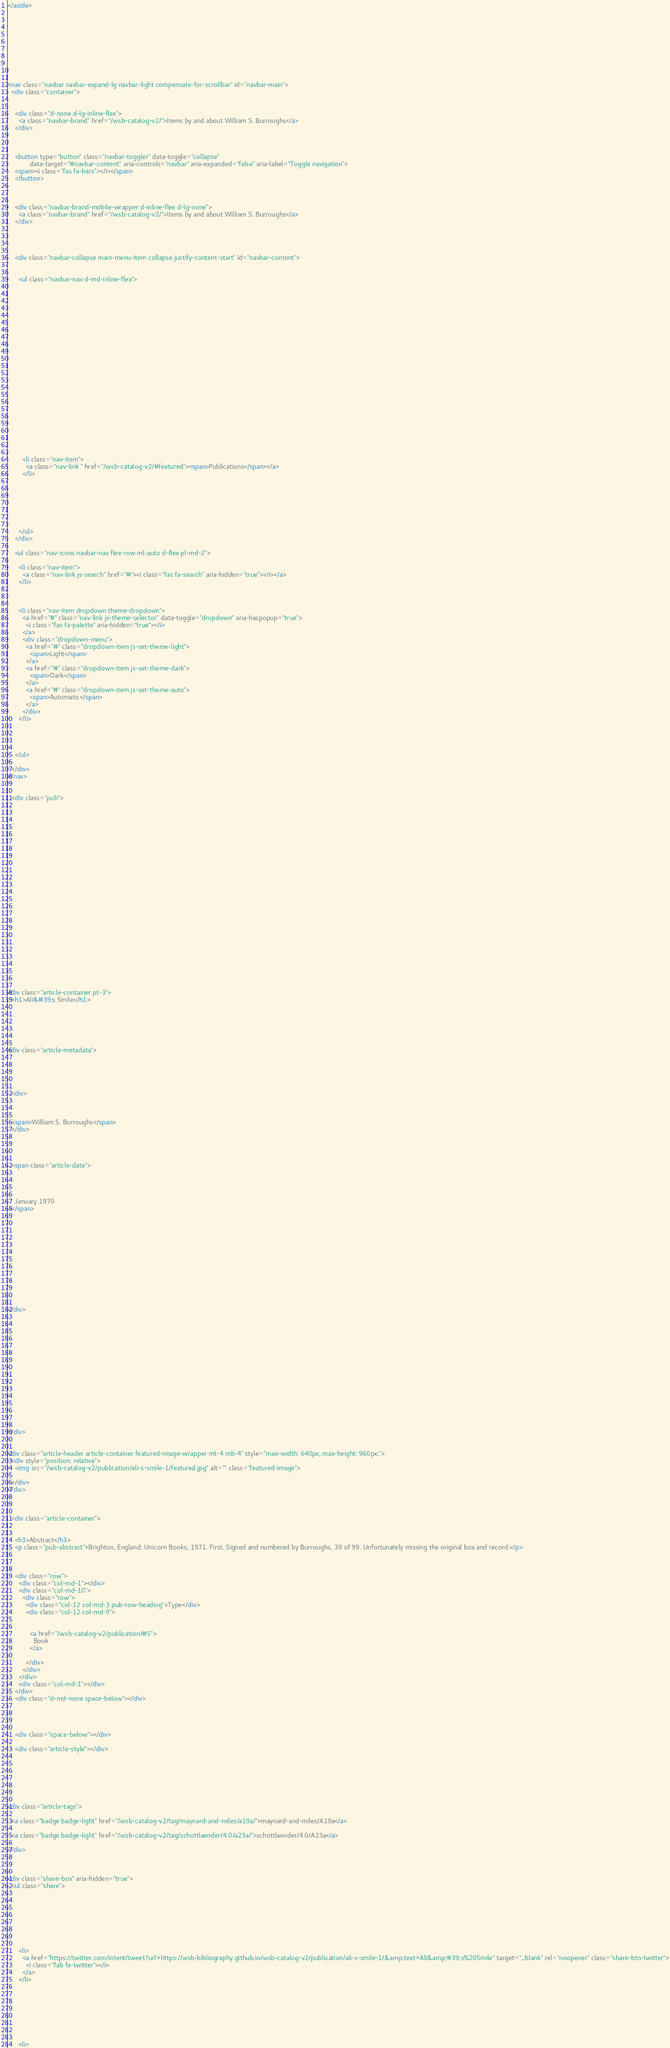<code> <loc_0><loc_0><loc_500><loc_500><_HTML_></aside>


  







<nav class="navbar navbar-expand-lg navbar-light compensate-for-scrollbar" id="navbar-main">
  <div class="container">

    
    <div class="d-none d-lg-inline-flex">
      <a class="navbar-brand" href="/wsb-catalog-v2/">Items by and about William S. Burroughs</a>
    </div>
    

    
    <button type="button" class="navbar-toggler" data-toggle="collapse"
            data-target="#navbar-content" aria-controls="navbar" aria-expanded="false" aria-label="Toggle navigation">
    <span><i class="fas fa-bars"></i></span>
    </button>
    

    
    <div class="navbar-brand-mobile-wrapper d-inline-flex d-lg-none">
      <a class="navbar-brand" href="/wsb-catalog-v2/">Items by and about William S. Burroughs</a>
    </div>
    

    
    
    <div class="navbar-collapse main-menu-item collapse justify-content-start" id="navbar-content">

      
      <ul class="navbar-nav d-md-inline-flex">
        

        

        
        
        
          
        

        
        
        
        
        
        
          
          
          
            
          
          
        

        <li class="nav-item">
          <a class="nav-link " href="/wsb-catalog-v2/#featured"><span>Publications</span></a>
        </li>

        
        

      

        
      </ul>
    </div>

    <ul class="nav-icons navbar-nav flex-row ml-auto d-flex pl-md-2">
      
      <li class="nav-item">
        <a class="nav-link js-search" href="#"><i class="fas fa-search" aria-hidden="true"></i></a>
      </li>
      

      
      <li class="nav-item dropdown theme-dropdown">
        <a href="#" class="nav-link js-theme-selector" data-toggle="dropdown" aria-haspopup="true">
          <i class="fas fa-palette" aria-hidden="true"></i>
        </a>
        <div class="dropdown-menu">
          <a href="#" class="dropdown-item js-set-theme-light">
            <span>Light</span>
          </a>
          <a href="#" class="dropdown-item js-set-theme-dark">
            <span>Dark</span>
          </a>
          <a href="#" class="dropdown-item js-set-theme-auto">
            <span>Automatic</span>
          </a>
        </div>
      </li>
      

      

    </ul>

  </div>
</nav>


  <div class="pub">

  




















  
  


<div class="article-container pt-3">
  <h1>Ali&#39;s Smile</h1>

  

  


<div class="article-metadata">

  
  
  
  
  <div>
    

  
  <span>William S. Burroughs</span>
  </div>
  
  

  
  <span class="article-date">
    
    
      
    
    January 1970
  </span>
  

  

  

  
  
  

  
  

</div>

  














</div>


<div class="article-header article-container featured-image-wrapper mt-4 mb-4" style="max-width: 640px; max-height: 960px;">
  <div style="position: relative">
    <img src="/wsb-catalog-v2/publication/ali-s-smile-1/featured.jpg" alt="" class="featured-image">
    
  </div>
</div>



  <div class="article-container">

    
    <h3>Abstract</h3>
    <p class="pub-abstract">Brighton, England: Unicorn Books, 1971. First. Signed and numbered by Burroughs, 39 of 99. Unfortunately missing the original box and record.</p>
    

    
    <div class="row">
      <div class="col-md-1"></div>
      <div class="col-md-10">
        <div class="row">
          <div class="col-12 col-md-3 pub-row-heading">Type</div>
          <div class="col-12 col-md-9">
            
            
            <a href="/wsb-catalog-v2/publication/#5">
              Book
            </a>
            
          </div>
        </div>
      </div>
      <div class="col-md-1"></div>
    </div>
    <div class="d-md-none space-below"></div>
    

    

    <div class="space-below"></div>

    <div class="article-style"></div>

    





<div class="article-tags">
  
  <a class="badge badge-light" href="/wsb-catalog-v2/tag/maynard-and-miles/a19a/">maynard-and-miles/A19a</a>
  
  <a class="badge badge-light" href="/wsb-catalog-v2/tag/schottlaender/4.0/a23a/">schottlaender/4.0/A23a</a>
  
</div>



<div class="share-box" aria-hidden="true">
  <ul class="share">
    
      
      
      
        
      
      
      
      <li>
        <a href="https://twitter.com/intent/tweet?url=https://wsb-bibliography.github.io/wsb-catalog-v2/publication/ali-s-smile-1/&amp;text=Ali&amp;#39;s%20Smile" target="_blank" rel="noopener" class="share-btn-twitter">
          <i class="fab fa-twitter"></i>
        </a>
      </li>
    
      
      
      
        
      
      
      
      <li></code> 